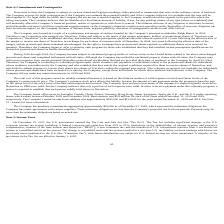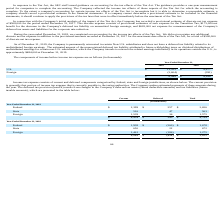According to Travelzoo's financial document, When did the U.S. government enact the Tax Cuts and Jobs Act? According to the financial document, December 22, 2017. The relevant text states: "On December 22, 2017, the U.S. government enacted the Tax Cuts and Jobs Act (the “Tax Act”). The Tax Act includes signif..." Also, What is the income before income tax expense for U.S. in 2019 and 2018 respectively? The document shows two values: $11,553 and $8,677 (in thousands). From the document: "U.S. $ 11,553 $ 8,677 U.S. $ 11,553 $ 8,677..." Also, What is the income before income tax expense for foreign in 2019 and 2018 respectively? The document shows two values: (2,604) and (391) (in thousands). From the document: "Foreign (2,604) (391) Foreign (2,604) (391)..." Also, can you calculate: What is the change in the income before income tax expense for U.S. between 2018 and 2019? Based on the calculation: 11,553-8,677, the result is 2876 (in thousands). This is based on the information: "U.S. $ 11,553 $ 8,677 U.S. $ 11,553 $ 8,677..." The key data points involved are: 11,553, 8,677. Also, can you calculate: What is the percentage change in the income before income tax expense for U.S. between 2018 and 2019? To answer this question, I need to perform calculations using the financial data. The calculation is: (11,553-8,677)/8,677, which equals 33.15 (percentage). This is based on the information: "U.S. $ 11,553 $ 8,677 U.S. $ 11,553 $ 8,677..." The key data points involved are: 11,553, 8,677. Also, can you calculate: What is the average of the total income before income tax expense for 2018 and 2019? To answer this question, I need to perform calculations using the financial data. The calculation is: (8,949+ 8,286)/2, which equals 8617.5 (in thousands). This is based on the information: "$ 8,949 $ 8,286 $ 8,949 $ 8,286..." The key data points involved are: 8,286, 8,949. 